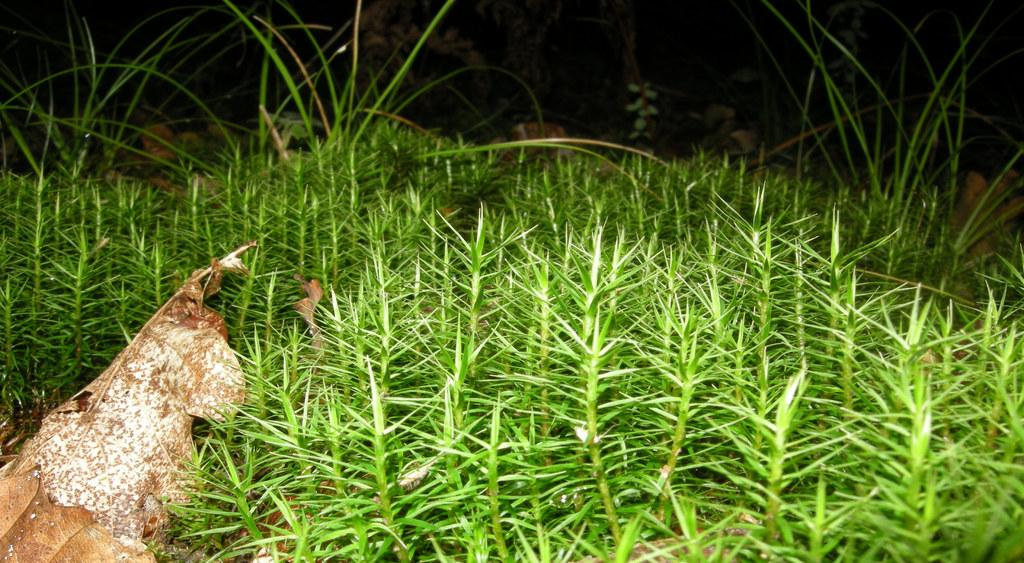What type of vegetation is present in the image? There is grass and plants in the image. What else can be found on the ground in the image? There are dried leaves and rocks in the image. How would you describe the overall lighting in the image? The background of the image is dark. What type of animal can be seen interacting with the plants in the image? There are no animals present in the image; it only features plants, dried leaves, rocks, and a dark background. Can you describe the color of the detail on the rocks in the image? There is no specific detail mentioned on the rocks, and the provided facts do not include information about the color of any details. 